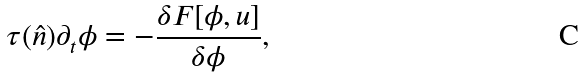<formula> <loc_0><loc_0><loc_500><loc_500>\tau ( \hat { n } ) \partial _ { t } \phi = - { \frac { \delta F [ \phi , u ] } { \delta \phi } } ,</formula> 